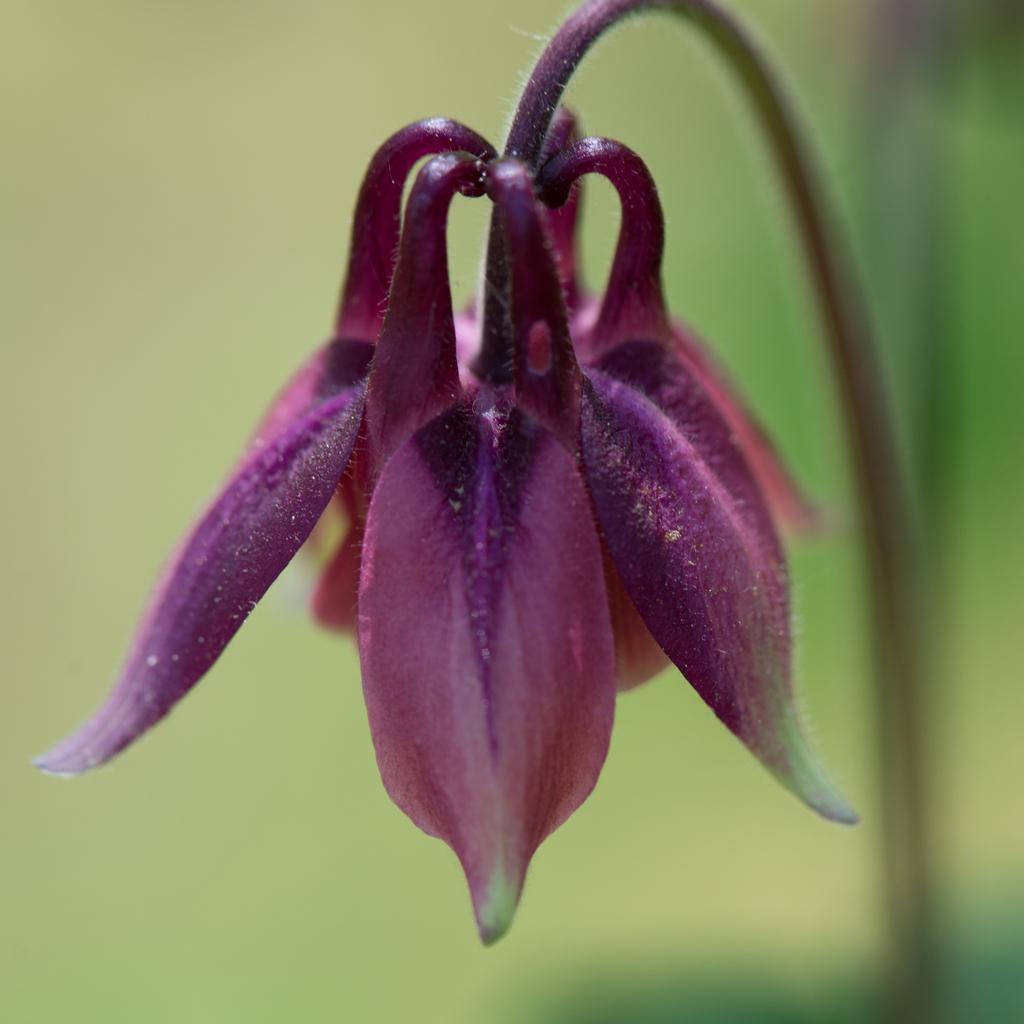In one or two sentences, can you explain what this image depicts? This image is taken outdoors. In this image the background is a little blurred and light green in color. On the right side of the image there is a plant with a stem and in the middle of the image there is a flower which is purple in color. 